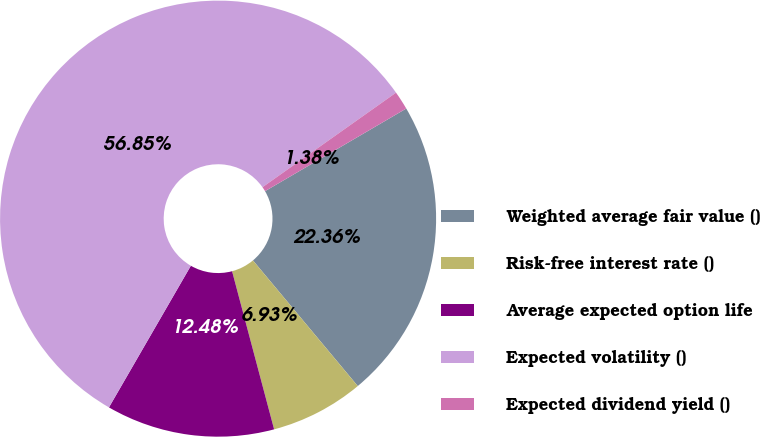Convert chart. <chart><loc_0><loc_0><loc_500><loc_500><pie_chart><fcel>Weighted average fair value ()<fcel>Risk-free interest rate ()<fcel>Average expected option life<fcel>Expected volatility ()<fcel>Expected dividend yield ()<nl><fcel>22.36%<fcel>6.93%<fcel>12.48%<fcel>56.85%<fcel>1.38%<nl></chart> 